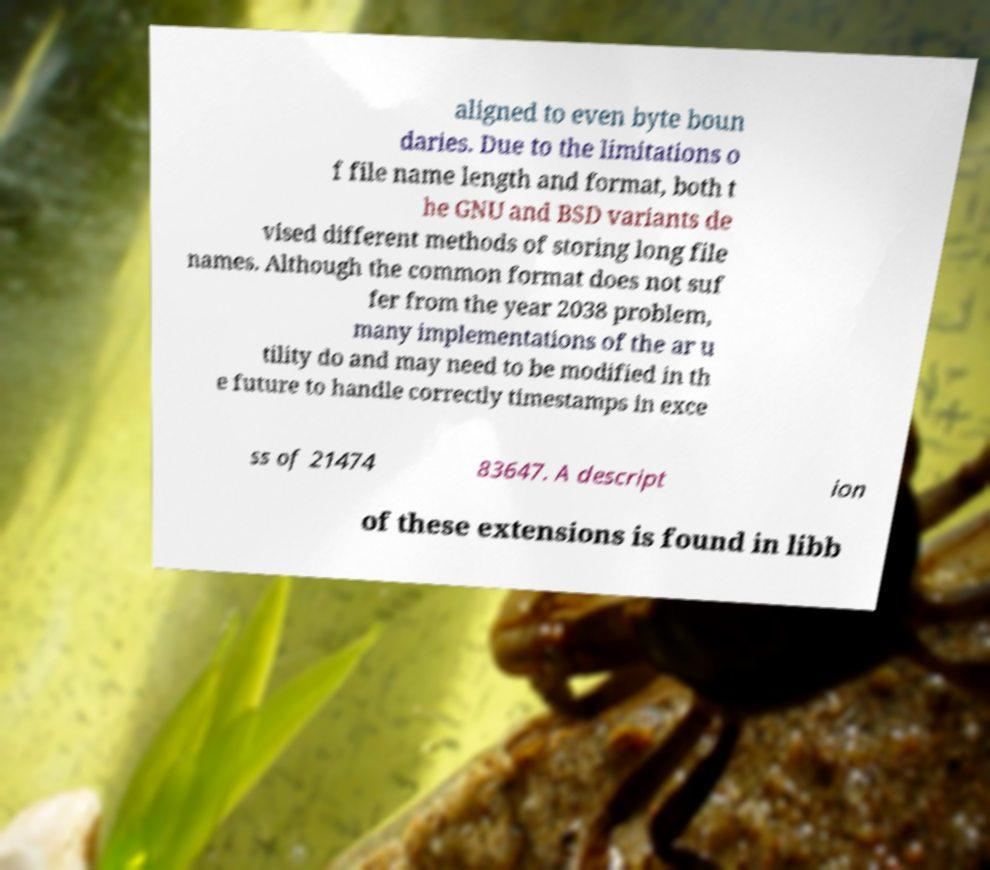Could you assist in decoding the text presented in this image and type it out clearly? aligned to even byte boun daries. Due to the limitations o f file name length and format, both t he GNU and BSD variants de vised different methods of storing long file names. Although the common format does not suf fer from the year 2038 problem, many implementations of the ar u tility do and may need to be modified in th e future to handle correctly timestamps in exce ss of 21474 83647. A descript ion of these extensions is found in libb 